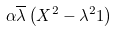Convert formula to latex. <formula><loc_0><loc_0><loc_500><loc_500>\alpha \overline { \lambda } \left ( X ^ { 2 } - \lambda ^ { 2 } 1 \right )</formula> 